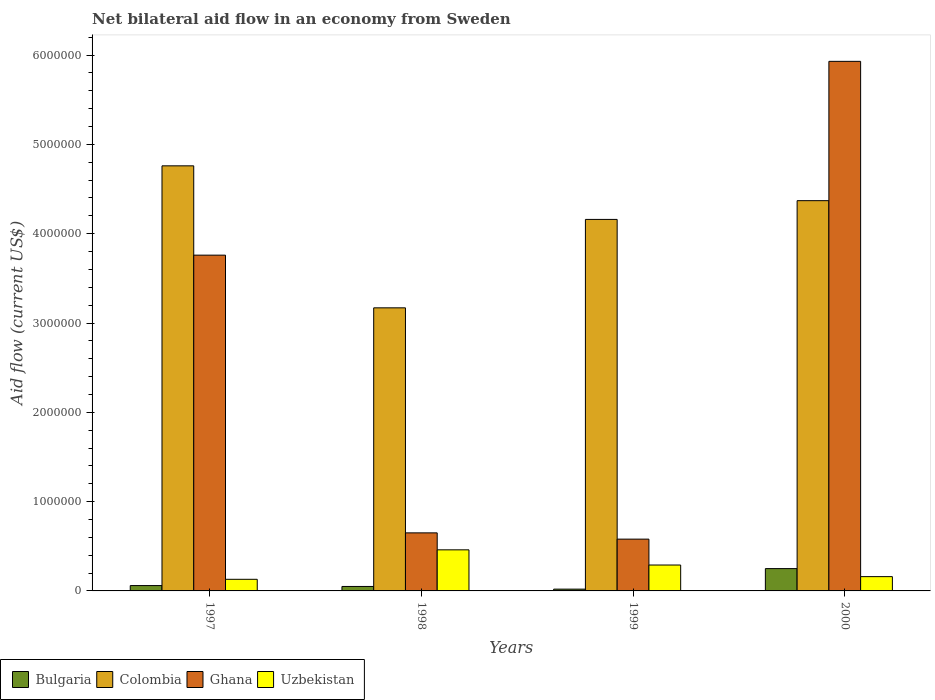How many different coloured bars are there?
Give a very brief answer. 4. Are the number of bars on each tick of the X-axis equal?
Ensure brevity in your answer.  Yes. How many bars are there on the 2nd tick from the left?
Offer a very short reply. 4. What is the label of the 3rd group of bars from the left?
Give a very brief answer. 1999. Across all years, what is the minimum net bilateral aid flow in Uzbekistan?
Provide a succinct answer. 1.30e+05. In which year was the net bilateral aid flow in Uzbekistan maximum?
Offer a terse response. 1998. What is the difference between the net bilateral aid flow in Ghana in 1998 and that in 2000?
Give a very brief answer. -5.28e+06. What is the difference between the net bilateral aid flow in Colombia in 2000 and the net bilateral aid flow in Uzbekistan in 1997?
Your response must be concise. 4.24e+06. What is the average net bilateral aid flow in Bulgaria per year?
Your answer should be very brief. 9.50e+04. In the year 1997, what is the difference between the net bilateral aid flow in Ghana and net bilateral aid flow in Uzbekistan?
Provide a short and direct response. 3.63e+06. In how many years, is the net bilateral aid flow in Uzbekistan greater than 4600000 US$?
Offer a very short reply. 0. What is the ratio of the net bilateral aid flow in Uzbekistan in 1997 to that in 1998?
Provide a succinct answer. 0.28. Is the difference between the net bilateral aid flow in Ghana in 1998 and 1999 greater than the difference between the net bilateral aid flow in Uzbekistan in 1998 and 1999?
Give a very brief answer. No. What is the difference between the highest and the lowest net bilateral aid flow in Colombia?
Your answer should be very brief. 1.59e+06. In how many years, is the net bilateral aid flow in Colombia greater than the average net bilateral aid flow in Colombia taken over all years?
Ensure brevity in your answer.  3. Is the sum of the net bilateral aid flow in Uzbekistan in 1997 and 1998 greater than the maximum net bilateral aid flow in Ghana across all years?
Offer a terse response. No. Is it the case that in every year, the sum of the net bilateral aid flow in Ghana and net bilateral aid flow in Uzbekistan is greater than the sum of net bilateral aid flow in Bulgaria and net bilateral aid flow in Colombia?
Provide a short and direct response. Yes. What does the 3rd bar from the left in 2000 represents?
Provide a succinct answer. Ghana. What does the 4th bar from the right in 2000 represents?
Your answer should be compact. Bulgaria. How many bars are there?
Make the answer very short. 16. How many years are there in the graph?
Your answer should be compact. 4. What is the difference between two consecutive major ticks on the Y-axis?
Provide a short and direct response. 1.00e+06. Are the values on the major ticks of Y-axis written in scientific E-notation?
Offer a terse response. No. Does the graph contain any zero values?
Make the answer very short. No. Where does the legend appear in the graph?
Offer a terse response. Bottom left. How many legend labels are there?
Your answer should be very brief. 4. What is the title of the graph?
Make the answer very short. Net bilateral aid flow in an economy from Sweden. Does "Upper middle income" appear as one of the legend labels in the graph?
Your answer should be very brief. No. What is the Aid flow (current US$) of Colombia in 1997?
Your answer should be very brief. 4.76e+06. What is the Aid flow (current US$) of Ghana in 1997?
Ensure brevity in your answer.  3.76e+06. What is the Aid flow (current US$) in Colombia in 1998?
Keep it short and to the point. 3.17e+06. What is the Aid flow (current US$) of Ghana in 1998?
Provide a succinct answer. 6.50e+05. What is the Aid flow (current US$) in Bulgaria in 1999?
Offer a very short reply. 2.00e+04. What is the Aid flow (current US$) in Colombia in 1999?
Offer a very short reply. 4.16e+06. What is the Aid flow (current US$) of Ghana in 1999?
Offer a very short reply. 5.80e+05. What is the Aid flow (current US$) of Colombia in 2000?
Offer a terse response. 4.37e+06. What is the Aid flow (current US$) of Ghana in 2000?
Your answer should be very brief. 5.93e+06. Across all years, what is the maximum Aid flow (current US$) of Colombia?
Offer a very short reply. 4.76e+06. Across all years, what is the maximum Aid flow (current US$) of Ghana?
Keep it short and to the point. 5.93e+06. Across all years, what is the maximum Aid flow (current US$) in Uzbekistan?
Provide a short and direct response. 4.60e+05. Across all years, what is the minimum Aid flow (current US$) in Colombia?
Keep it short and to the point. 3.17e+06. Across all years, what is the minimum Aid flow (current US$) in Ghana?
Your response must be concise. 5.80e+05. Across all years, what is the minimum Aid flow (current US$) in Uzbekistan?
Offer a terse response. 1.30e+05. What is the total Aid flow (current US$) of Colombia in the graph?
Provide a succinct answer. 1.65e+07. What is the total Aid flow (current US$) of Ghana in the graph?
Your answer should be very brief. 1.09e+07. What is the total Aid flow (current US$) of Uzbekistan in the graph?
Ensure brevity in your answer.  1.04e+06. What is the difference between the Aid flow (current US$) in Colombia in 1997 and that in 1998?
Keep it short and to the point. 1.59e+06. What is the difference between the Aid flow (current US$) in Ghana in 1997 and that in 1998?
Provide a succinct answer. 3.11e+06. What is the difference between the Aid flow (current US$) in Uzbekistan in 1997 and that in 1998?
Your answer should be very brief. -3.30e+05. What is the difference between the Aid flow (current US$) of Colombia in 1997 and that in 1999?
Offer a very short reply. 6.00e+05. What is the difference between the Aid flow (current US$) in Ghana in 1997 and that in 1999?
Your answer should be very brief. 3.18e+06. What is the difference between the Aid flow (current US$) in Uzbekistan in 1997 and that in 1999?
Provide a succinct answer. -1.60e+05. What is the difference between the Aid flow (current US$) of Bulgaria in 1997 and that in 2000?
Your answer should be compact. -1.90e+05. What is the difference between the Aid flow (current US$) of Ghana in 1997 and that in 2000?
Your response must be concise. -2.17e+06. What is the difference between the Aid flow (current US$) in Colombia in 1998 and that in 1999?
Give a very brief answer. -9.90e+05. What is the difference between the Aid flow (current US$) in Uzbekistan in 1998 and that in 1999?
Your answer should be very brief. 1.70e+05. What is the difference between the Aid flow (current US$) of Colombia in 1998 and that in 2000?
Provide a succinct answer. -1.20e+06. What is the difference between the Aid flow (current US$) of Ghana in 1998 and that in 2000?
Your answer should be very brief. -5.28e+06. What is the difference between the Aid flow (current US$) in Uzbekistan in 1998 and that in 2000?
Offer a terse response. 3.00e+05. What is the difference between the Aid flow (current US$) in Colombia in 1999 and that in 2000?
Your response must be concise. -2.10e+05. What is the difference between the Aid flow (current US$) in Ghana in 1999 and that in 2000?
Give a very brief answer. -5.35e+06. What is the difference between the Aid flow (current US$) of Uzbekistan in 1999 and that in 2000?
Provide a short and direct response. 1.30e+05. What is the difference between the Aid flow (current US$) in Bulgaria in 1997 and the Aid flow (current US$) in Colombia in 1998?
Make the answer very short. -3.11e+06. What is the difference between the Aid flow (current US$) of Bulgaria in 1997 and the Aid flow (current US$) of Ghana in 1998?
Provide a succinct answer. -5.90e+05. What is the difference between the Aid flow (current US$) in Bulgaria in 1997 and the Aid flow (current US$) in Uzbekistan in 1998?
Your answer should be very brief. -4.00e+05. What is the difference between the Aid flow (current US$) of Colombia in 1997 and the Aid flow (current US$) of Ghana in 1998?
Give a very brief answer. 4.11e+06. What is the difference between the Aid flow (current US$) of Colombia in 1997 and the Aid flow (current US$) of Uzbekistan in 1998?
Keep it short and to the point. 4.30e+06. What is the difference between the Aid flow (current US$) in Ghana in 1997 and the Aid flow (current US$) in Uzbekistan in 1998?
Offer a very short reply. 3.30e+06. What is the difference between the Aid flow (current US$) in Bulgaria in 1997 and the Aid flow (current US$) in Colombia in 1999?
Offer a very short reply. -4.10e+06. What is the difference between the Aid flow (current US$) of Bulgaria in 1997 and the Aid flow (current US$) of Ghana in 1999?
Your answer should be compact. -5.20e+05. What is the difference between the Aid flow (current US$) in Bulgaria in 1997 and the Aid flow (current US$) in Uzbekistan in 1999?
Your response must be concise. -2.30e+05. What is the difference between the Aid flow (current US$) of Colombia in 1997 and the Aid flow (current US$) of Ghana in 1999?
Provide a succinct answer. 4.18e+06. What is the difference between the Aid flow (current US$) in Colombia in 1997 and the Aid flow (current US$) in Uzbekistan in 1999?
Your answer should be compact. 4.47e+06. What is the difference between the Aid flow (current US$) of Ghana in 1997 and the Aid flow (current US$) of Uzbekistan in 1999?
Keep it short and to the point. 3.47e+06. What is the difference between the Aid flow (current US$) of Bulgaria in 1997 and the Aid flow (current US$) of Colombia in 2000?
Offer a terse response. -4.31e+06. What is the difference between the Aid flow (current US$) of Bulgaria in 1997 and the Aid flow (current US$) of Ghana in 2000?
Your response must be concise. -5.87e+06. What is the difference between the Aid flow (current US$) of Bulgaria in 1997 and the Aid flow (current US$) of Uzbekistan in 2000?
Offer a very short reply. -1.00e+05. What is the difference between the Aid flow (current US$) in Colombia in 1997 and the Aid flow (current US$) in Ghana in 2000?
Provide a short and direct response. -1.17e+06. What is the difference between the Aid flow (current US$) in Colombia in 1997 and the Aid flow (current US$) in Uzbekistan in 2000?
Your answer should be very brief. 4.60e+06. What is the difference between the Aid flow (current US$) in Ghana in 1997 and the Aid flow (current US$) in Uzbekistan in 2000?
Your answer should be very brief. 3.60e+06. What is the difference between the Aid flow (current US$) of Bulgaria in 1998 and the Aid flow (current US$) of Colombia in 1999?
Your response must be concise. -4.11e+06. What is the difference between the Aid flow (current US$) in Bulgaria in 1998 and the Aid flow (current US$) in Ghana in 1999?
Your answer should be compact. -5.30e+05. What is the difference between the Aid flow (current US$) of Bulgaria in 1998 and the Aid flow (current US$) of Uzbekistan in 1999?
Your answer should be compact. -2.40e+05. What is the difference between the Aid flow (current US$) of Colombia in 1998 and the Aid flow (current US$) of Ghana in 1999?
Offer a very short reply. 2.59e+06. What is the difference between the Aid flow (current US$) of Colombia in 1998 and the Aid flow (current US$) of Uzbekistan in 1999?
Give a very brief answer. 2.88e+06. What is the difference between the Aid flow (current US$) of Ghana in 1998 and the Aid flow (current US$) of Uzbekistan in 1999?
Offer a terse response. 3.60e+05. What is the difference between the Aid flow (current US$) in Bulgaria in 1998 and the Aid flow (current US$) in Colombia in 2000?
Your answer should be compact. -4.32e+06. What is the difference between the Aid flow (current US$) of Bulgaria in 1998 and the Aid flow (current US$) of Ghana in 2000?
Your answer should be very brief. -5.88e+06. What is the difference between the Aid flow (current US$) in Colombia in 1998 and the Aid flow (current US$) in Ghana in 2000?
Keep it short and to the point. -2.76e+06. What is the difference between the Aid flow (current US$) in Colombia in 1998 and the Aid flow (current US$) in Uzbekistan in 2000?
Your response must be concise. 3.01e+06. What is the difference between the Aid flow (current US$) of Ghana in 1998 and the Aid flow (current US$) of Uzbekistan in 2000?
Your answer should be very brief. 4.90e+05. What is the difference between the Aid flow (current US$) in Bulgaria in 1999 and the Aid flow (current US$) in Colombia in 2000?
Ensure brevity in your answer.  -4.35e+06. What is the difference between the Aid flow (current US$) in Bulgaria in 1999 and the Aid flow (current US$) in Ghana in 2000?
Provide a succinct answer. -5.91e+06. What is the difference between the Aid flow (current US$) of Bulgaria in 1999 and the Aid flow (current US$) of Uzbekistan in 2000?
Offer a terse response. -1.40e+05. What is the difference between the Aid flow (current US$) in Colombia in 1999 and the Aid flow (current US$) in Ghana in 2000?
Give a very brief answer. -1.77e+06. What is the difference between the Aid flow (current US$) of Colombia in 1999 and the Aid flow (current US$) of Uzbekistan in 2000?
Offer a very short reply. 4.00e+06. What is the difference between the Aid flow (current US$) in Ghana in 1999 and the Aid flow (current US$) in Uzbekistan in 2000?
Make the answer very short. 4.20e+05. What is the average Aid flow (current US$) in Bulgaria per year?
Give a very brief answer. 9.50e+04. What is the average Aid flow (current US$) of Colombia per year?
Your answer should be compact. 4.12e+06. What is the average Aid flow (current US$) of Ghana per year?
Make the answer very short. 2.73e+06. In the year 1997, what is the difference between the Aid flow (current US$) of Bulgaria and Aid flow (current US$) of Colombia?
Provide a succinct answer. -4.70e+06. In the year 1997, what is the difference between the Aid flow (current US$) in Bulgaria and Aid flow (current US$) in Ghana?
Ensure brevity in your answer.  -3.70e+06. In the year 1997, what is the difference between the Aid flow (current US$) in Colombia and Aid flow (current US$) in Uzbekistan?
Your answer should be very brief. 4.63e+06. In the year 1997, what is the difference between the Aid flow (current US$) of Ghana and Aid flow (current US$) of Uzbekistan?
Make the answer very short. 3.63e+06. In the year 1998, what is the difference between the Aid flow (current US$) in Bulgaria and Aid flow (current US$) in Colombia?
Provide a short and direct response. -3.12e+06. In the year 1998, what is the difference between the Aid flow (current US$) in Bulgaria and Aid flow (current US$) in Ghana?
Provide a succinct answer. -6.00e+05. In the year 1998, what is the difference between the Aid flow (current US$) of Bulgaria and Aid flow (current US$) of Uzbekistan?
Keep it short and to the point. -4.10e+05. In the year 1998, what is the difference between the Aid flow (current US$) of Colombia and Aid flow (current US$) of Ghana?
Your answer should be very brief. 2.52e+06. In the year 1998, what is the difference between the Aid flow (current US$) of Colombia and Aid flow (current US$) of Uzbekistan?
Offer a very short reply. 2.71e+06. In the year 1999, what is the difference between the Aid flow (current US$) of Bulgaria and Aid flow (current US$) of Colombia?
Keep it short and to the point. -4.14e+06. In the year 1999, what is the difference between the Aid flow (current US$) of Bulgaria and Aid flow (current US$) of Ghana?
Offer a terse response. -5.60e+05. In the year 1999, what is the difference between the Aid flow (current US$) of Colombia and Aid flow (current US$) of Ghana?
Provide a succinct answer. 3.58e+06. In the year 1999, what is the difference between the Aid flow (current US$) of Colombia and Aid flow (current US$) of Uzbekistan?
Your answer should be compact. 3.87e+06. In the year 1999, what is the difference between the Aid flow (current US$) in Ghana and Aid flow (current US$) in Uzbekistan?
Your answer should be very brief. 2.90e+05. In the year 2000, what is the difference between the Aid flow (current US$) in Bulgaria and Aid flow (current US$) in Colombia?
Offer a terse response. -4.12e+06. In the year 2000, what is the difference between the Aid flow (current US$) in Bulgaria and Aid flow (current US$) in Ghana?
Your answer should be compact. -5.68e+06. In the year 2000, what is the difference between the Aid flow (current US$) in Colombia and Aid flow (current US$) in Ghana?
Your response must be concise. -1.56e+06. In the year 2000, what is the difference between the Aid flow (current US$) in Colombia and Aid flow (current US$) in Uzbekistan?
Your response must be concise. 4.21e+06. In the year 2000, what is the difference between the Aid flow (current US$) of Ghana and Aid flow (current US$) of Uzbekistan?
Provide a succinct answer. 5.77e+06. What is the ratio of the Aid flow (current US$) in Colombia in 1997 to that in 1998?
Your answer should be compact. 1.5. What is the ratio of the Aid flow (current US$) of Ghana in 1997 to that in 1998?
Offer a terse response. 5.78. What is the ratio of the Aid flow (current US$) of Uzbekistan in 1997 to that in 1998?
Make the answer very short. 0.28. What is the ratio of the Aid flow (current US$) of Bulgaria in 1997 to that in 1999?
Provide a short and direct response. 3. What is the ratio of the Aid flow (current US$) in Colombia in 1997 to that in 1999?
Make the answer very short. 1.14. What is the ratio of the Aid flow (current US$) of Ghana in 1997 to that in 1999?
Your answer should be compact. 6.48. What is the ratio of the Aid flow (current US$) in Uzbekistan in 1997 to that in 1999?
Give a very brief answer. 0.45. What is the ratio of the Aid flow (current US$) in Bulgaria in 1997 to that in 2000?
Your answer should be compact. 0.24. What is the ratio of the Aid flow (current US$) in Colombia in 1997 to that in 2000?
Make the answer very short. 1.09. What is the ratio of the Aid flow (current US$) in Ghana in 1997 to that in 2000?
Offer a very short reply. 0.63. What is the ratio of the Aid flow (current US$) of Uzbekistan in 1997 to that in 2000?
Give a very brief answer. 0.81. What is the ratio of the Aid flow (current US$) in Colombia in 1998 to that in 1999?
Ensure brevity in your answer.  0.76. What is the ratio of the Aid flow (current US$) of Ghana in 1998 to that in 1999?
Ensure brevity in your answer.  1.12. What is the ratio of the Aid flow (current US$) of Uzbekistan in 1998 to that in 1999?
Give a very brief answer. 1.59. What is the ratio of the Aid flow (current US$) of Colombia in 1998 to that in 2000?
Offer a terse response. 0.73. What is the ratio of the Aid flow (current US$) in Ghana in 1998 to that in 2000?
Offer a terse response. 0.11. What is the ratio of the Aid flow (current US$) of Uzbekistan in 1998 to that in 2000?
Keep it short and to the point. 2.88. What is the ratio of the Aid flow (current US$) in Bulgaria in 1999 to that in 2000?
Make the answer very short. 0.08. What is the ratio of the Aid flow (current US$) in Colombia in 1999 to that in 2000?
Ensure brevity in your answer.  0.95. What is the ratio of the Aid flow (current US$) of Ghana in 1999 to that in 2000?
Offer a terse response. 0.1. What is the ratio of the Aid flow (current US$) in Uzbekistan in 1999 to that in 2000?
Your response must be concise. 1.81. What is the difference between the highest and the second highest Aid flow (current US$) of Colombia?
Your response must be concise. 3.90e+05. What is the difference between the highest and the second highest Aid flow (current US$) in Ghana?
Provide a succinct answer. 2.17e+06. What is the difference between the highest and the lowest Aid flow (current US$) of Colombia?
Provide a short and direct response. 1.59e+06. What is the difference between the highest and the lowest Aid flow (current US$) in Ghana?
Ensure brevity in your answer.  5.35e+06. 